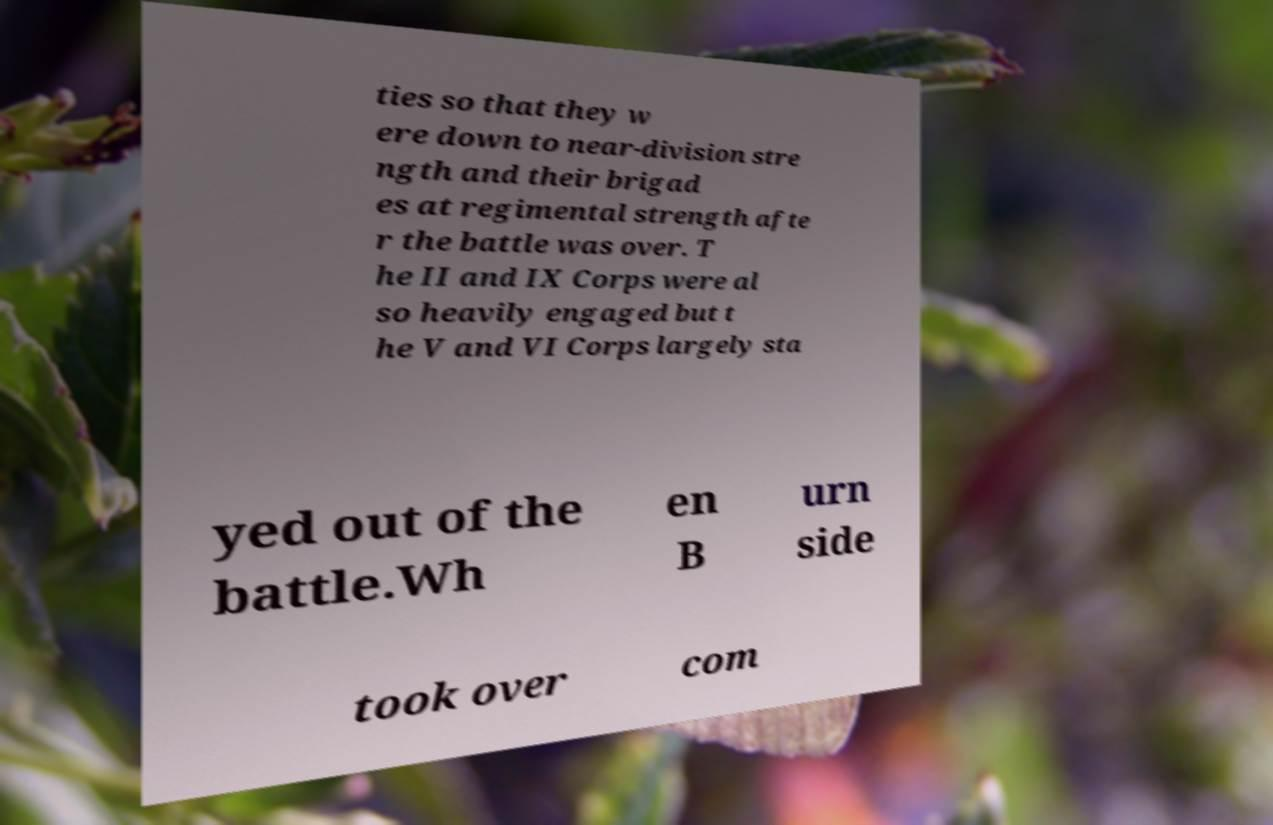Please identify and transcribe the text found in this image. ties so that they w ere down to near-division stre ngth and their brigad es at regimental strength afte r the battle was over. T he II and IX Corps were al so heavily engaged but t he V and VI Corps largely sta yed out of the battle.Wh en B urn side took over com 